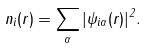Convert formula to latex. <formula><loc_0><loc_0><loc_500><loc_500>n _ { i } ( { r } ) = \sum _ { \alpha } | \psi _ { i \alpha } ( { r } ) | ^ { 2 } .</formula> 